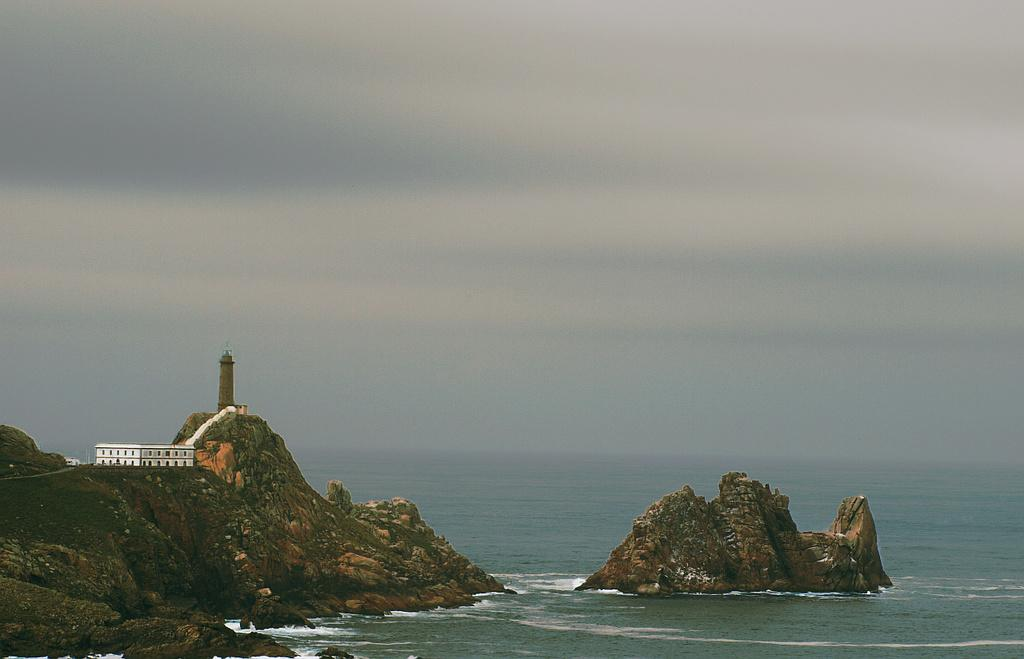What is the main feature of the image? There is an ocean in the image. What can be seen on the left side of the image? There is a rock surface on the left side of the image. What is visible in the sky in the background of the image? There are clouds in the sky in the background of the image. How many chairs are placed on the rock surface in the image? There are no chairs present in the image. What type of cart is visible in the ocean in the image? There is no cart visible in the ocean in the image. 